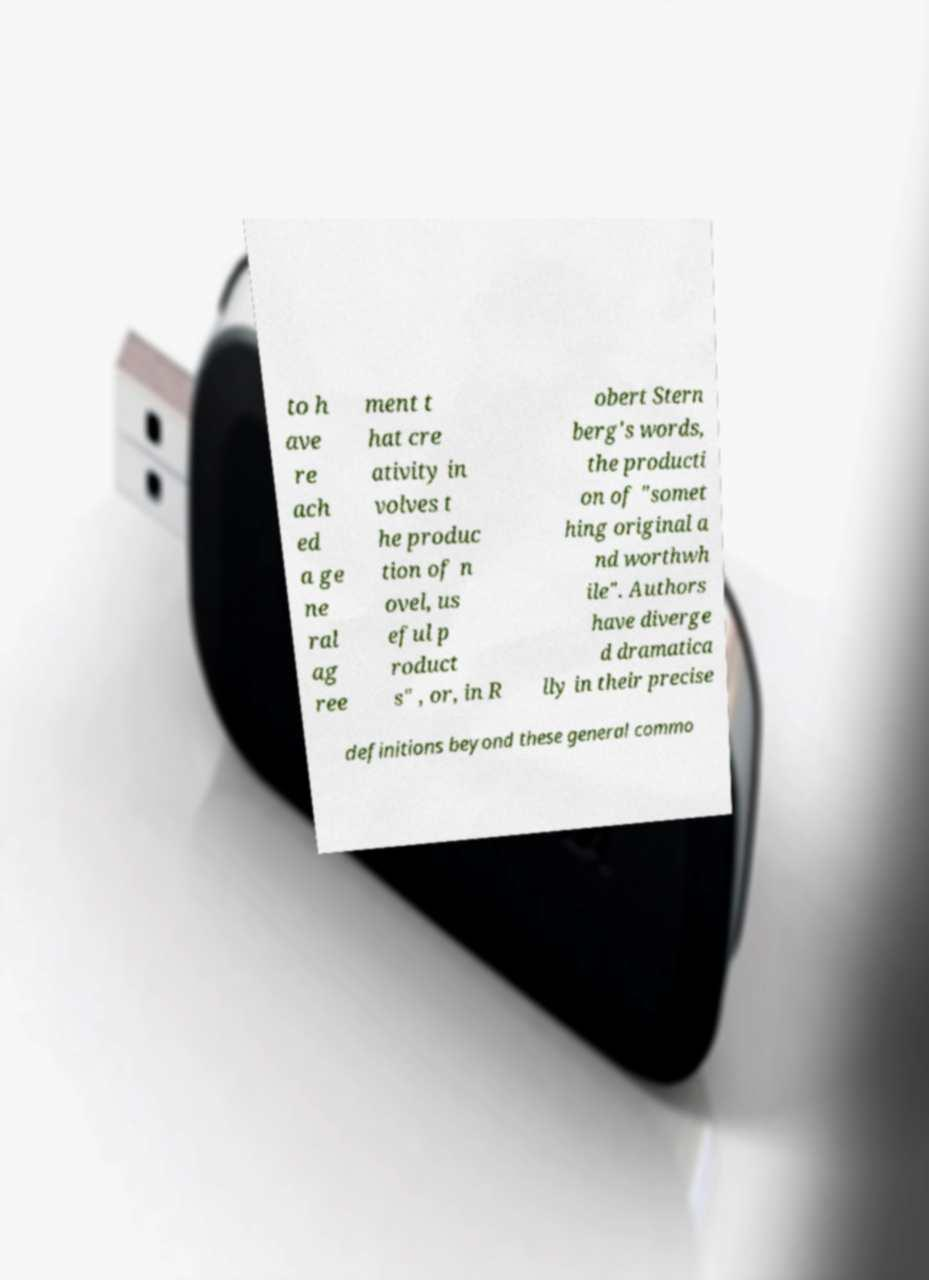Could you assist in decoding the text presented in this image and type it out clearly? to h ave re ach ed a ge ne ral ag ree ment t hat cre ativity in volves t he produc tion of n ovel, us eful p roduct s" , or, in R obert Stern berg's words, the producti on of "somet hing original a nd worthwh ile". Authors have diverge d dramatica lly in their precise definitions beyond these general commo 